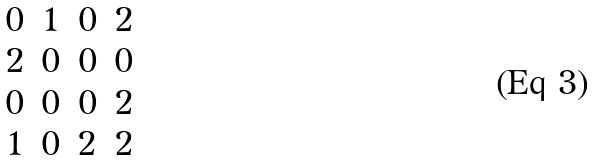Convert formula to latex. <formula><loc_0><loc_0><loc_500><loc_500>\begin{matrix} 0 & 1 & 0 & 2 \\ 2 & 0 & 0 & 0 \\ 0 & 0 & 0 & 2 \\ 1 & 0 & 2 & 2 \\ \end{matrix}</formula> 